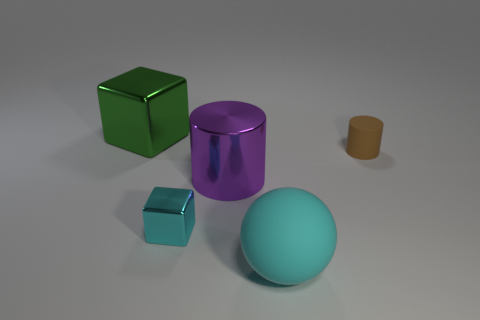Do the tiny cyan thing and the green thing have the same shape?
Provide a short and direct response. Yes. How many other things are made of the same material as the tiny brown object?
Ensure brevity in your answer.  1. What number of big green metallic objects have the same shape as the cyan matte thing?
Ensure brevity in your answer.  0. What is the color of the object that is both behind the large purple shiny cylinder and in front of the green metallic cube?
Make the answer very short. Brown. How many tiny yellow rubber balls are there?
Offer a very short reply. 0. Is the rubber cylinder the same size as the green metal cube?
Give a very brief answer. No. Is there a large rubber sphere of the same color as the tiny shiny thing?
Offer a terse response. Yes. There is a big object behind the purple metallic object; is it the same shape as the big purple metallic thing?
Provide a succinct answer. No. How many brown things are the same size as the shiny cylinder?
Make the answer very short. 0. There is a cylinder that is right of the purple shiny cylinder; what number of tiny metallic things are right of it?
Ensure brevity in your answer.  0. 